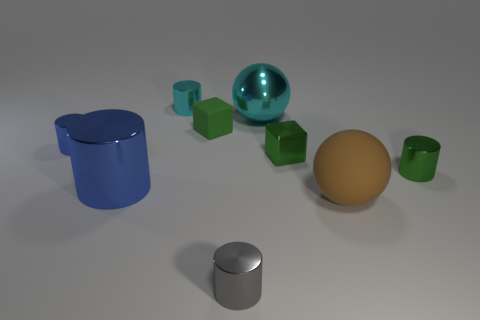Does the small metal cube have the same color as the tiny matte thing?
Provide a short and direct response. Yes. What number of objects are either shiny things to the right of the small blue object or big metallic spheres?
Keep it short and to the point. 6. What shape is the blue thing that is the same size as the brown ball?
Make the answer very short. Cylinder. Is the size of the sphere that is in front of the large blue metallic object the same as the cyan metal thing behind the large cyan metallic thing?
Your answer should be compact. No. There is a cube that is the same material as the large blue thing; what is its color?
Offer a terse response. Green. Does the cyan object right of the tiny cyan cylinder have the same material as the green thing that is on the right side of the matte sphere?
Offer a terse response. Yes. Are there any cyan metallic objects that have the same size as the cyan cylinder?
Provide a short and direct response. No. There is a metal cylinder that is in front of the blue cylinder that is right of the small blue thing; what size is it?
Offer a very short reply. Small. How many metallic objects are the same color as the small matte thing?
Provide a succinct answer. 2. The small green thing to the left of the small shiny thing in front of the brown object is what shape?
Your answer should be compact. Cube. 